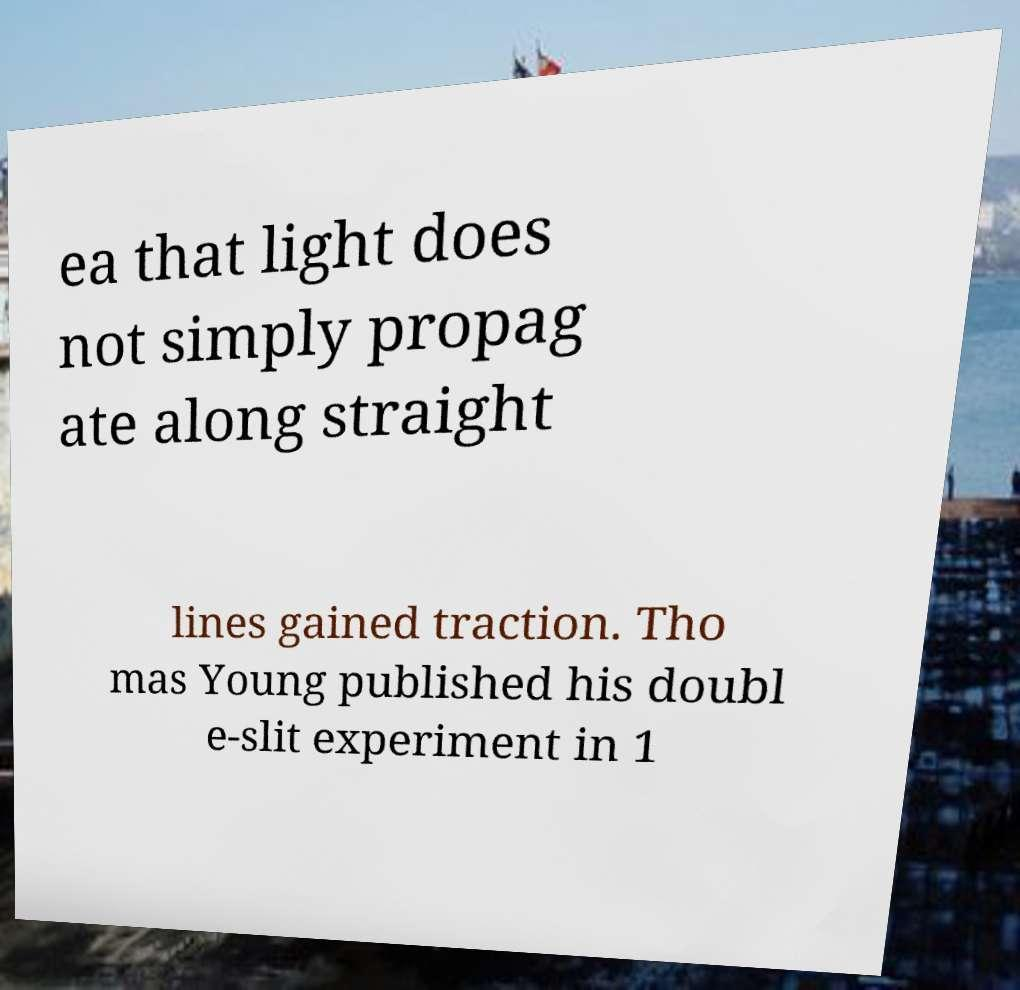Can you read and provide the text displayed in the image?This photo seems to have some interesting text. Can you extract and type it out for me? ea that light does not simply propag ate along straight lines gained traction. Tho mas Young published his doubl e-slit experiment in 1 